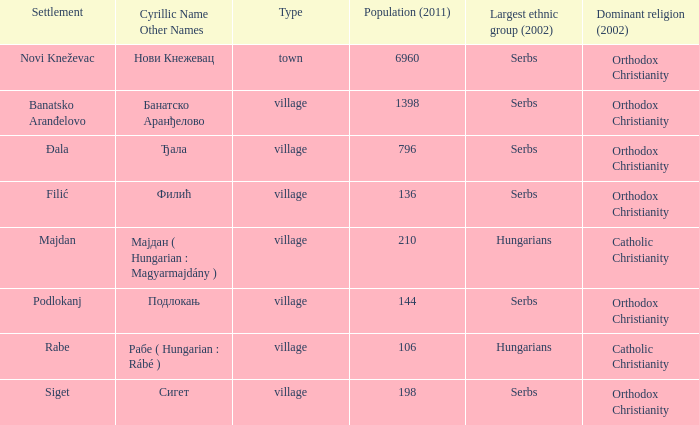What is the cyrillic and other name of rabe? Рабе ( Hungarian : Rábé ). 